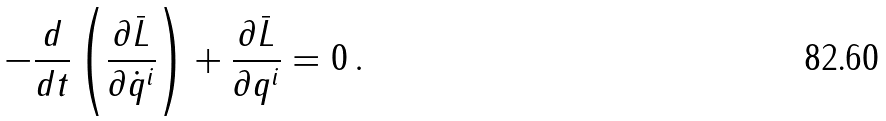<formula> <loc_0><loc_0><loc_500><loc_500>- \frac { d } { d t } \left ( \frac { \partial { \bar { L } } } { \partial { \dot { q } } ^ { i } } \right ) + \frac { \partial { \bar { L } } } { \partial q ^ { i } } = 0 \, .</formula> 